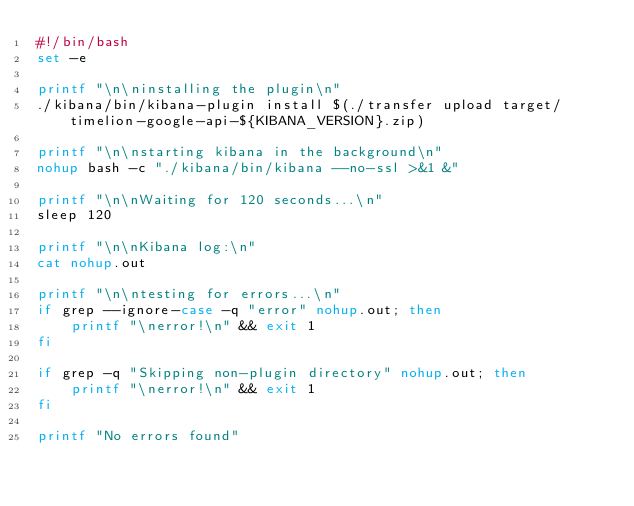<code> <loc_0><loc_0><loc_500><loc_500><_Bash_>#!/bin/bash
set -e

printf "\n\ninstalling the plugin\n"
./kibana/bin/kibana-plugin install $(./transfer upload target/timelion-google-api-${KIBANA_VERSION}.zip)

printf "\n\nstarting kibana in the background\n"
nohup bash -c "./kibana/bin/kibana --no-ssl >&1 &"

printf "\n\nWaiting for 120 seconds...\n"
sleep 120

printf "\n\nKibana log:\n"
cat nohup.out

printf "\n\ntesting for errors...\n"
if grep --ignore-case -q "error" nohup.out; then
    printf "\nerror!\n" && exit 1 
fi

if grep -q "Skipping non-plugin directory" nohup.out; then
    printf "\nerror!\n" && exit 1 
fi

printf "No errors found"
</code> 